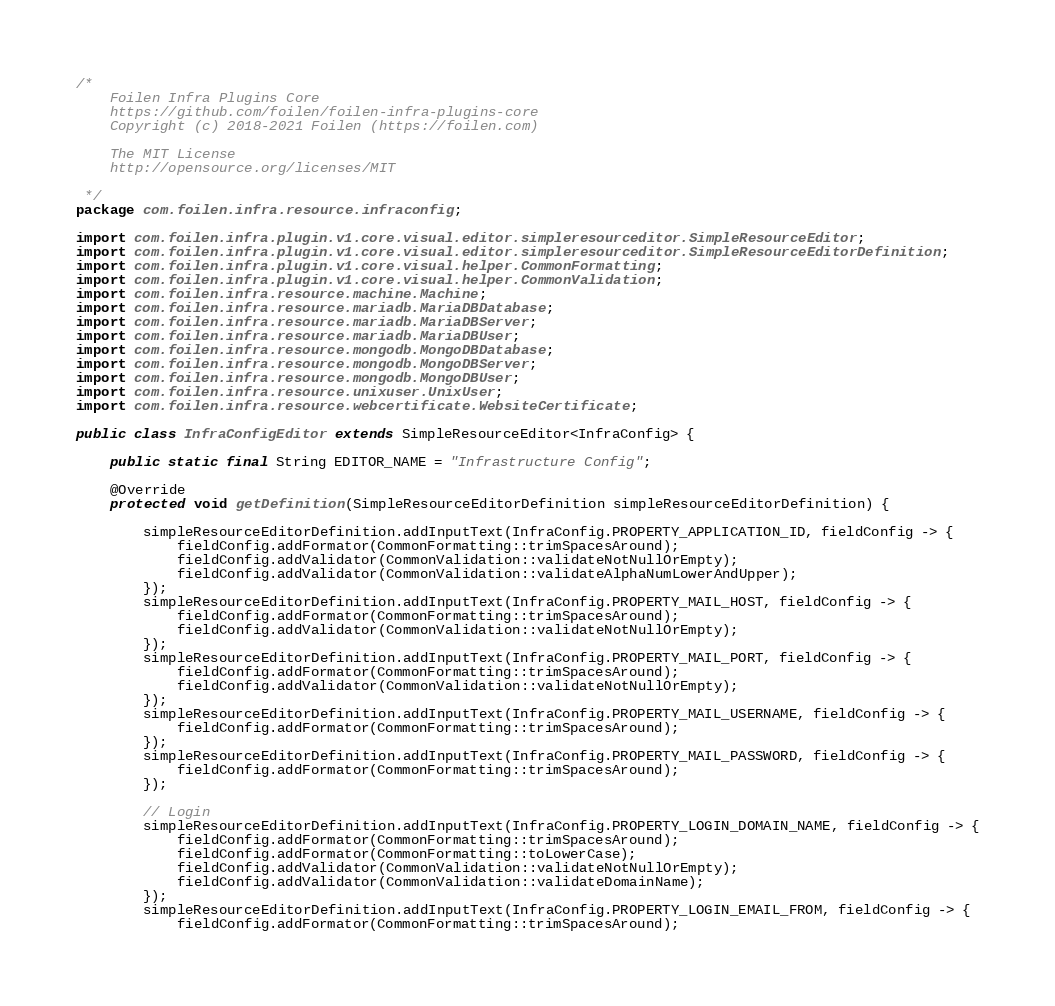Convert code to text. <code><loc_0><loc_0><loc_500><loc_500><_Java_>/*
    Foilen Infra Plugins Core
    https://github.com/foilen/foilen-infra-plugins-core
    Copyright (c) 2018-2021 Foilen (https://foilen.com)

    The MIT License
    http://opensource.org/licenses/MIT

 */
package com.foilen.infra.resource.infraconfig;

import com.foilen.infra.plugin.v1.core.visual.editor.simpleresourceditor.SimpleResourceEditor;
import com.foilen.infra.plugin.v1.core.visual.editor.simpleresourceditor.SimpleResourceEditorDefinition;
import com.foilen.infra.plugin.v1.core.visual.helper.CommonFormatting;
import com.foilen.infra.plugin.v1.core.visual.helper.CommonValidation;
import com.foilen.infra.resource.machine.Machine;
import com.foilen.infra.resource.mariadb.MariaDBDatabase;
import com.foilen.infra.resource.mariadb.MariaDBServer;
import com.foilen.infra.resource.mariadb.MariaDBUser;
import com.foilen.infra.resource.mongodb.MongoDBDatabase;
import com.foilen.infra.resource.mongodb.MongoDBServer;
import com.foilen.infra.resource.mongodb.MongoDBUser;
import com.foilen.infra.resource.unixuser.UnixUser;
import com.foilen.infra.resource.webcertificate.WebsiteCertificate;

public class InfraConfigEditor extends SimpleResourceEditor<InfraConfig> {

    public static final String EDITOR_NAME = "Infrastructure Config";

    @Override
    protected void getDefinition(SimpleResourceEditorDefinition simpleResourceEditorDefinition) {

        simpleResourceEditorDefinition.addInputText(InfraConfig.PROPERTY_APPLICATION_ID, fieldConfig -> {
            fieldConfig.addFormator(CommonFormatting::trimSpacesAround);
            fieldConfig.addValidator(CommonValidation::validateNotNullOrEmpty);
            fieldConfig.addValidator(CommonValidation::validateAlphaNumLowerAndUpper);
        });
        simpleResourceEditorDefinition.addInputText(InfraConfig.PROPERTY_MAIL_HOST, fieldConfig -> {
            fieldConfig.addFormator(CommonFormatting::trimSpacesAround);
            fieldConfig.addValidator(CommonValidation::validateNotNullOrEmpty);
        });
        simpleResourceEditorDefinition.addInputText(InfraConfig.PROPERTY_MAIL_PORT, fieldConfig -> {
            fieldConfig.addFormator(CommonFormatting::trimSpacesAround);
            fieldConfig.addValidator(CommonValidation::validateNotNullOrEmpty);
        });
        simpleResourceEditorDefinition.addInputText(InfraConfig.PROPERTY_MAIL_USERNAME, fieldConfig -> {
            fieldConfig.addFormator(CommonFormatting::trimSpacesAround);
        });
        simpleResourceEditorDefinition.addInputText(InfraConfig.PROPERTY_MAIL_PASSWORD, fieldConfig -> {
            fieldConfig.addFormator(CommonFormatting::trimSpacesAround);
        });

        // Login
        simpleResourceEditorDefinition.addInputText(InfraConfig.PROPERTY_LOGIN_DOMAIN_NAME, fieldConfig -> {
            fieldConfig.addFormator(CommonFormatting::trimSpacesAround);
            fieldConfig.addFormator(CommonFormatting::toLowerCase);
            fieldConfig.addValidator(CommonValidation::validateNotNullOrEmpty);
            fieldConfig.addValidator(CommonValidation::validateDomainName);
        });
        simpleResourceEditorDefinition.addInputText(InfraConfig.PROPERTY_LOGIN_EMAIL_FROM, fieldConfig -> {
            fieldConfig.addFormator(CommonFormatting::trimSpacesAround);</code> 